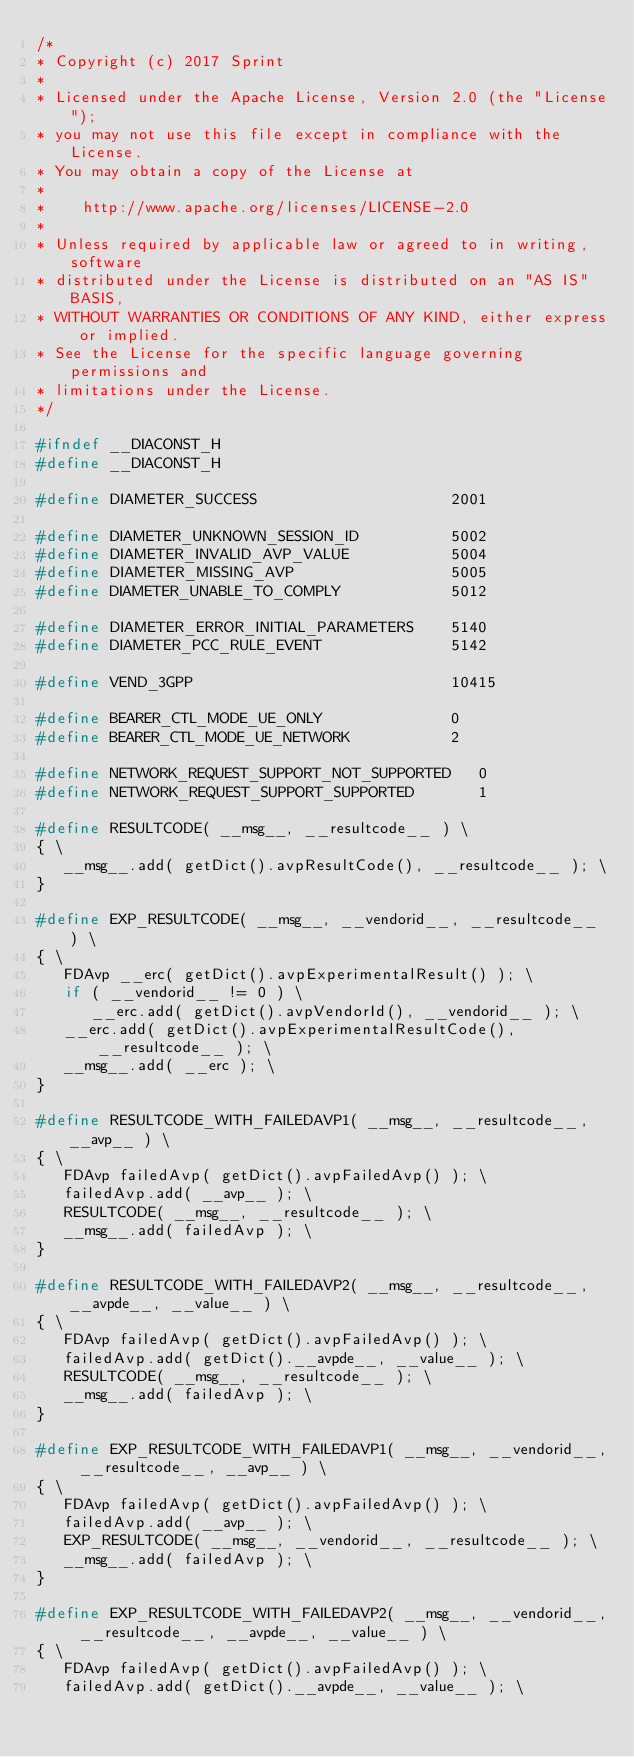<code> <loc_0><loc_0><loc_500><loc_500><_C_>/*
* Copyright (c) 2017 Sprint
*
* Licensed under the Apache License, Version 2.0 (the "License");
* you may not use this file except in compliance with the License.
* You may obtain a copy of the License at
*
*    http://www.apache.org/licenses/LICENSE-2.0
*
* Unless required by applicable law or agreed to in writing, software
* distributed under the License is distributed on an "AS IS" BASIS,
* WITHOUT WARRANTIES OR CONDITIONS OF ANY KIND, either express or implied.
* See the License for the specific language governing permissions and
* limitations under the License.
*/

#ifndef __DIACONST_H
#define __DIACONST_H

#define DIAMETER_SUCCESS                     2001

#define DIAMETER_UNKNOWN_SESSION_ID          5002
#define DIAMETER_INVALID_AVP_VALUE           5004
#define DIAMETER_MISSING_AVP                 5005
#define DIAMETER_UNABLE_TO_COMPLY            5012

#define DIAMETER_ERROR_INITIAL_PARAMETERS    5140
#define DIAMETER_PCC_RULE_EVENT              5142

#define VEND_3GPP                            10415

#define BEARER_CTL_MODE_UE_ONLY              0
#define BEARER_CTL_MODE_UE_NETWORK           2

#define NETWORK_REQUEST_SUPPORT_NOT_SUPPORTED   0
#define NETWORK_REQUEST_SUPPORT_SUPPORTED       1

#define RESULTCODE( __msg__, __resultcode__ ) \
{ \
   __msg__.add( getDict().avpResultCode(), __resultcode__ ); \
}

#define EXP_RESULTCODE( __msg__, __vendorid__, __resultcode__ ) \
{ \
   FDAvp __erc( getDict().avpExperimentalResult() ); \
   if ( __vendorid__ != 0 ) \
      __erc.add( getDict().avpVendorId(), __vendorid__ ); \
   __erc.add( getDict().avpExperimentalResultCode(), __resultcode__ ); \
   __msg__.add( __erc ); \
}

#define RESULTCODE_WITH_FAILEDAVP1( __msg__, __resultcode__, __avp__ ) \
{ \
   FDAvp failedAvp( getDict().avpFailedAvp() ); \
   failedAvp.add( __avp__ ); \
   RESULTCODE( __msg__, __resultcode__ ); \
   __msg__.add( failedAvp ); \
}

#define RESULTCODE_WITH_FAILEDAVP2( __msg__, __resultcode__, __avpde__, __value__ ) \
{ \
   FDAvp failedAvp( getDict().avpFailedAvp() ); \
   failedAvp.add( getDict().__avpde__, __value__ ); \
   RESULTCODE( __msg__, __resultcode__ ); \
   __msg__.add( failedAvp ); \
}

#define EXP_RESULTCODE_WITH_FAILEDAVP1( __msg__, __vendorid__, __resultcode__, __avp__ ) \
{ \
   FDAvp failedAvp( getDict().avpFailedAvp() ); \
   failedAvp.add( __avp__ ); \
   EXP_RESULTCODE( __msg__, __vendorid__, __resultcode__ ); \
   __msg__.add( failedAvp ); \
}

#define EXP_RESULTCODE_WITH_FAILEDAVP2( __msg__, __vendorid__, __resultcode__, __avpde__, __value__ ) \
{ \
   FDAvp failedAvp( getDict().avpFailedAvp() ); \
   failedAvp.add( getDict().__avpde__, __value__ ); \</code> 